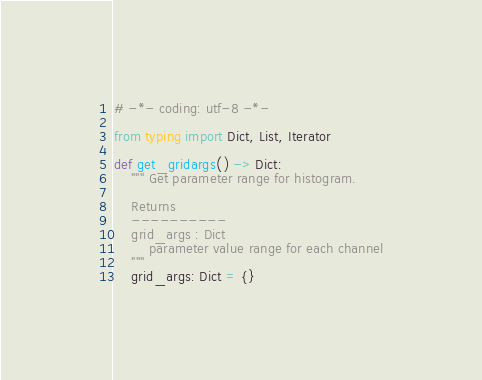Convert code to text. <code><loc_0><loc_0><loc_500><loc_500><_Python_># -*- coding: utf-8 -*-

from typing import Dict, List, Iterator

def get_gridargs() -> Dict:
    """ Get parameter range for histogram.

    Returns
    ----------
    grid_args : Dict
        parameter value range for each channel
    """
    grid_args: Dict = {}</code> 